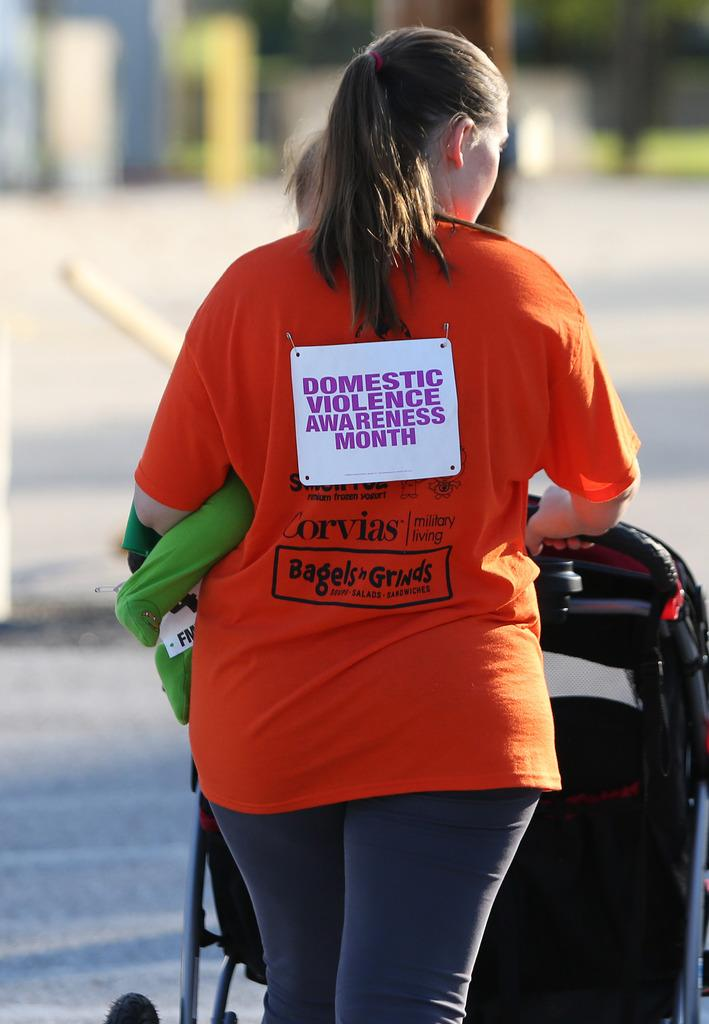Who is the main subject in the image? There is a woman in the center of the image. What else can be seen in the image besides the woman? There is a trolley on the road in the image. What type of jam is the woman spreading on the carriage in the image? There is no jam or carriage present in the image. How many legs does the woman have in the image? The image only shows the woman from the waist up, so it is impossible to determine the number of legs she has in the image. 